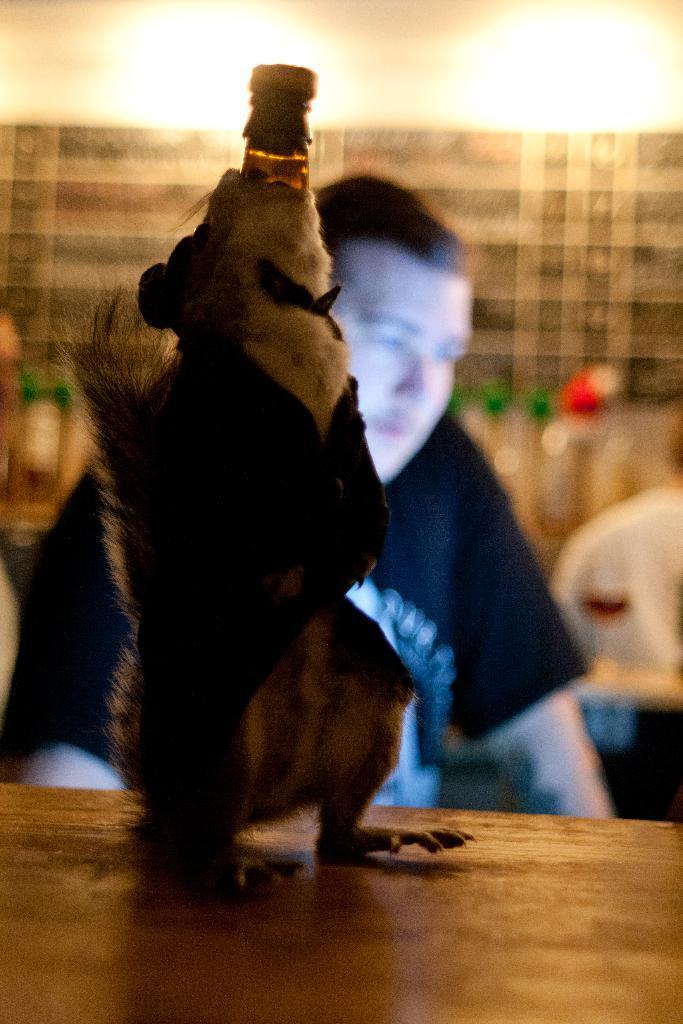In one or two sentences, can you explain what this image depicts? In this image there is a mice on the table and it is holding some object in its mouth. Behind the mice there is a person. In the background of the image there is a wall. There are lights and there a few objects. 